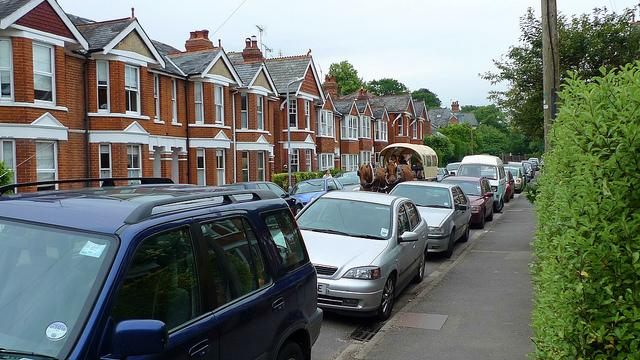Which conveyance pictured here uses less gas? wagon 